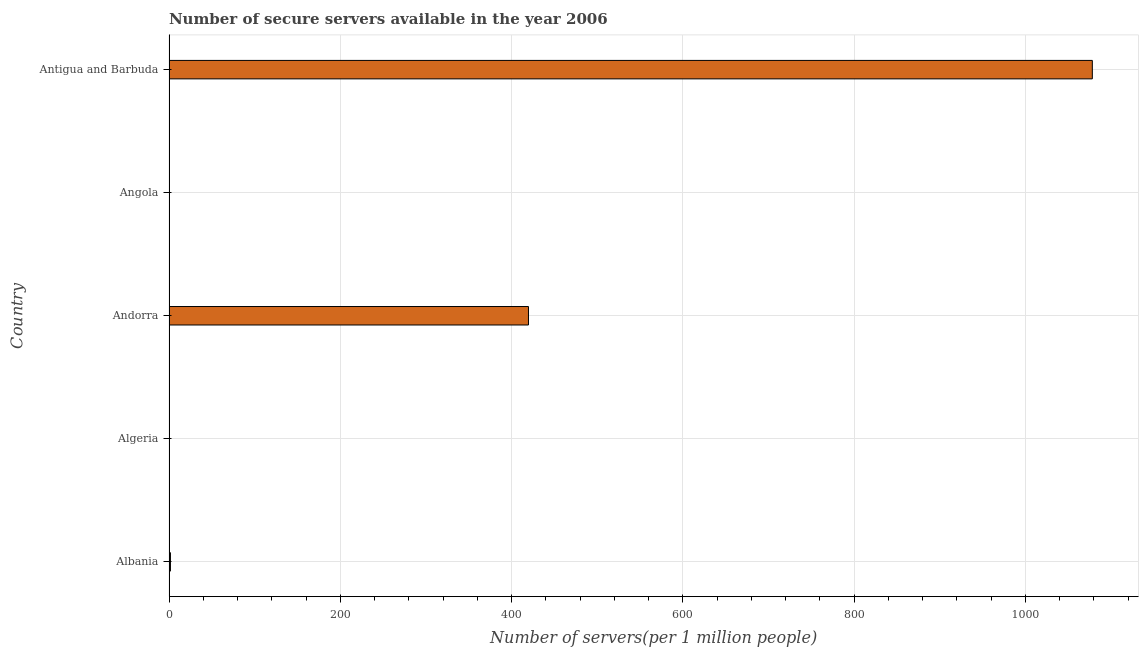Does the graph contain any zero values?
Your answer should be compact. No. What is the title of the graph?
Give a very brief answer. Number of secure servers available in the year 2006. What is the label or title of the X-axis?
Make the answer very short. Number of servers(per 1 million people). What is the label or title of the Y-axis?
Offer a very short reply. Country. What is the number of secure internet servers in Antigua and Barbuda?
Your answer should be very brief. 1078.27. Across all countries, what is the maximum number of secure internet servers?
Keep it short and to the point. 1078.27. Across all countries, what is the minimum number of secure internet servers?
Make the answer very short. 0.18. In which country was the number of secure internet servers maximum?
Provide a short and direct response. Antigua and Barbuda. In which country was the number of secure internet servers minimum?
Your answer should be very brief. Algeria. What is the sum of the number of secure internet servers?
Offer a terse response. 1500.24. What is the difference between the number of secure internet servers in Andorra and Antigua and Barbuda?
Provide a succinct answer. -658.47. What is the average number of secure internet servers per country?
Offer a very short reply. 300.05. What is the median number of secure internet servers?
Offer a terse response. 1.67. In how many countries, is the number of secure internet servers greater than 1080 ?
Your answer should be very brief. 0. What is the ratio of the number of secure internet servers in Andorra to that in Angola?
Keep it short and to the point. 1297.29. Is the number of secure internet servers in Algeria less than that in Andorra?
Offer a terse response. Yes. What is the difference between the highest and the second highest number of secure internet servers?
Offer a terse response. 658.47. What is the difference between the highest and the lowest number of secure internet servers?
Your answer should be compact. 1078.09. Are all the bars in the graph horizontal?
Give a very brief answer. Yes. How many countries are there in the graph?
Make the answer very short. 5. What is the difference between two consecutive major ticks on the X-axis?
Ensure brevity in your answer.  200. Are the values on the major ticks of X-axis written in scientific E-notation?
Make the answer very short. No. What is the Number of servers(per 1 million people) in Albania?
Offer a terse response. 1.67. What is the Number of servers(per 1 million people) of Algeria?
Keep it short and to the point. 0.18. What is the Number of servers(per 1 million people) of Andorra?
Ensure brevity in your answer.  419.8. What is the Number of servers(per 1 million people) of Angola?
Make the answer very short. 0.32. What is the Number of servers(per 1 million people) in Antigua and Barbuda?
Provide a succinct answer. 1078.27. What is the difference between the Number of servers(per 1 million people) in Albania and Algeria?
Your answer should be compact. 1.49. What is the difference between the Number of servers(per 1 million people) in Albania and Andorra?
Offer a terse response. -418.13. What is the difference between the Number of servers(per 1 million people) in Albania and Angola?
Make the answer very short. 1.35. What is the difference between the Number of servers(per 1 million people) in Albania and Antigua and Barbuda?
Your answer should be very brief. -1076.6. What is the difference between the Number of servers(per 1 million people) in Algeria and Andorra?
Your answer should be very brief. -419.62. What is the difference between the Number of servers(per 1 million people) in Algeria and Angola?
Make the answer very short. -0.15. What is the difference between the Number of servers(per 1 million people) in Algeria and Antigua and Barbuda?
Your response must be concise. -1078.09. What is the difference between the Number of servers(per 1 million people) in Andorra and Angola?
Offer a very short reply. 419.48. What is the difference between the Number of servers(per 1 million people) in Andorra and Antigua and Barbuda?
Offer a very short reply. -658.47. What is the difference between the Number of servers(per 1 million people) in Angola and Antigua and Barbuda?
Your answer should be very brief. -1077.95. What is the ratio of the Number of servers(per 1 million people) in Albania to that in Algeria?
Ensure brevity in your answer.  9.4. What is the ratio of the Number of servers(per 1 million people) in Albania to that in Andorra?
Make the answer very short. 0. What is the ratio of the Number of servers(per 1 million people) in Albania to that in Angola?
Keep it short and to the point. 5.16. What is the ratio of the Number of servers(per 1 million people) in Albania to that in Antigua and Barbuda?
Make the answer very short. 0. What is the ratio of the Number of servers(per 1 million people) in Algeria to that in Andorra?
Keep it short and to the point. 0. What is the ratio of the Number of servers(per 1 million people) in Algeria to that in Angola?
Offer a very short reply. 0.55. What is the ratio of the Number of servers(per 1 million people) in Algeria to that in Antigua and Barbuda?
Provide a succinct answer. 0. What is the ratio of the Number of servers(per 1 million people) in Andorra to that in Angola?
Provide a short and direct response. 1297.29. What is the ratio of the Number of servers(per 1 million people) in Andorra to that in Antigua and Barbuda?
Give a very brief answer. 0.39. What is the ratio of the Number of servers(per 1 million people) in Angola to that in Antigua and Barbuda?
Ensure brevity in your answer.  0. 